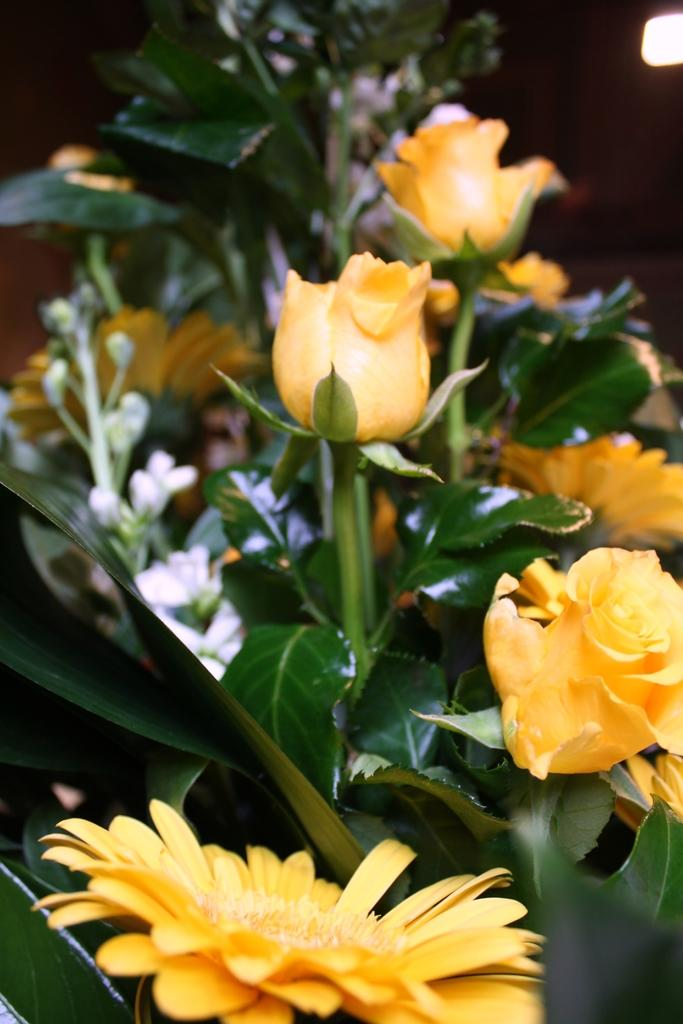What types of plants can be seen in the image? There are flowers and leaves in the image. How are the flowers and leaves arranged in the image? The flowers and leaves are arranged in a bouquet. What colors are the flowers in the image? The flowers are in yellow and white colors. Can you tell me how much honey is being collected by the bees in the image? There are no bees or honey present in the image; it features a bouquet of flowers and leaves. What type of hook is used to hang the flowers in the image? There is no hook present in the image; the flowers and leaves are arranged in a bouquet. 